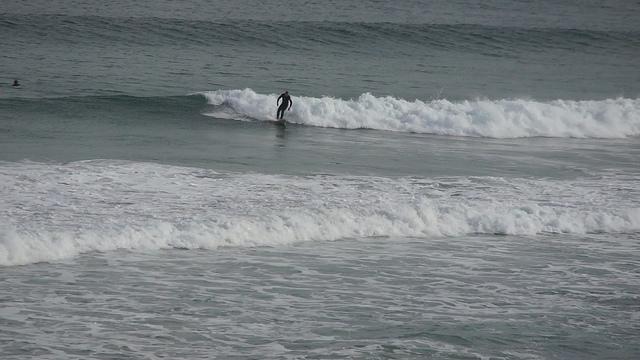How many waves are in the picture?
Give a very brief answer. 3. How many people are in the water?
Give a very brief answer. 2. 